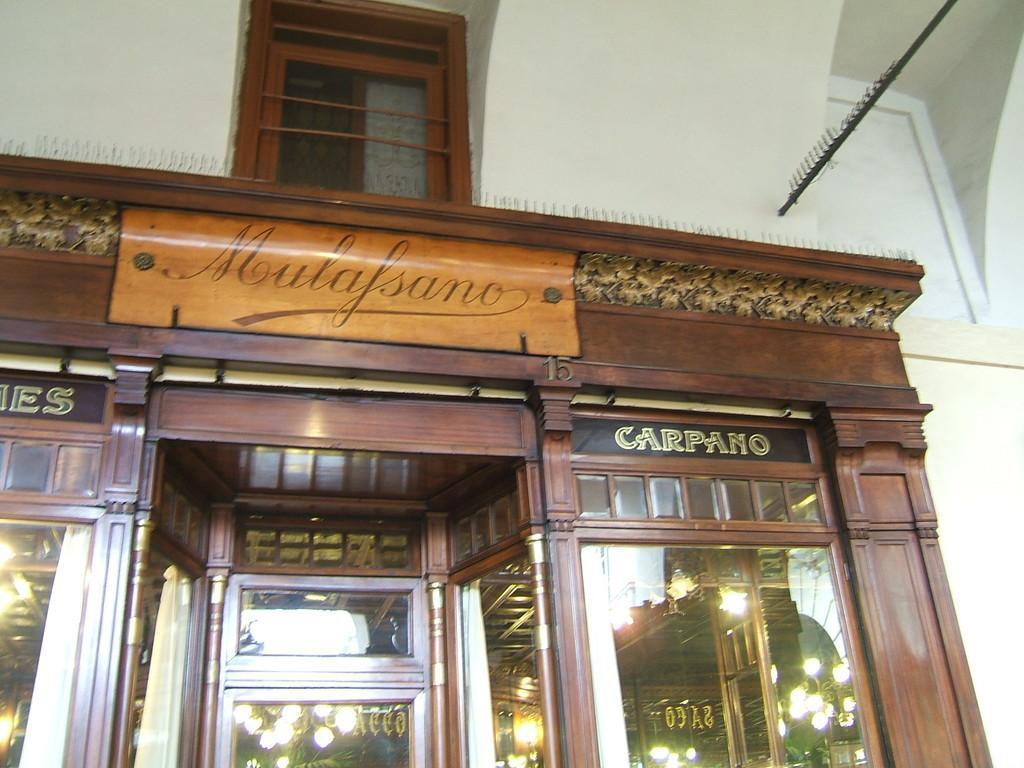Could you give a brief overview of what you see in this image? In the picture we can see a building wall with a shop in it, and the shop is modified with a wooden frame and glasses and inside the shop we can see some lights and on the top of the shop we can see a window with a glass to it and beside it we can see a rod and some hangings to it. 